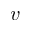<formula> <loc_0><loc_0><loc_500><loc_500>v</formula> 